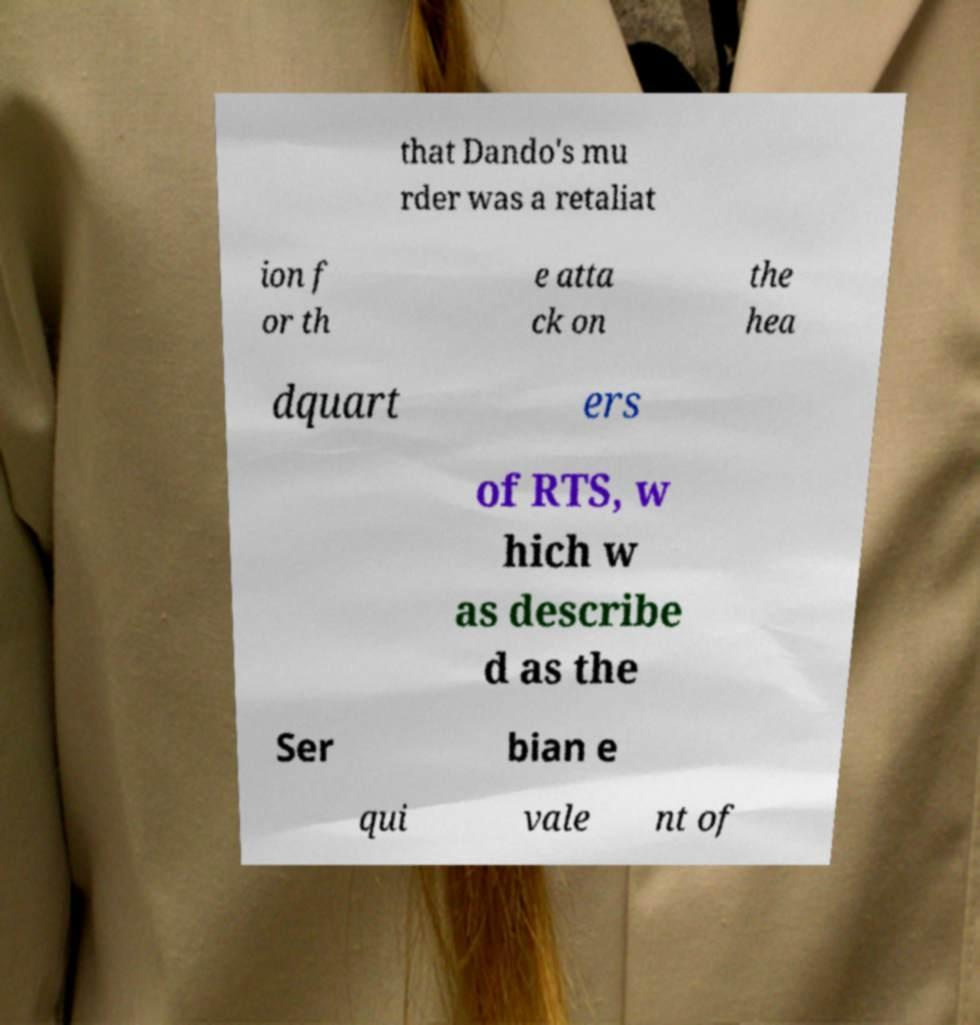For documentation purposes, I need the text within this image transcribed. Could you provide that? that Dando's mu rder was a retaliat ion f or th e atta ck on the hea dquart ers of RTS, w hich w as describe d as the Ser bian e qui vale nt of 